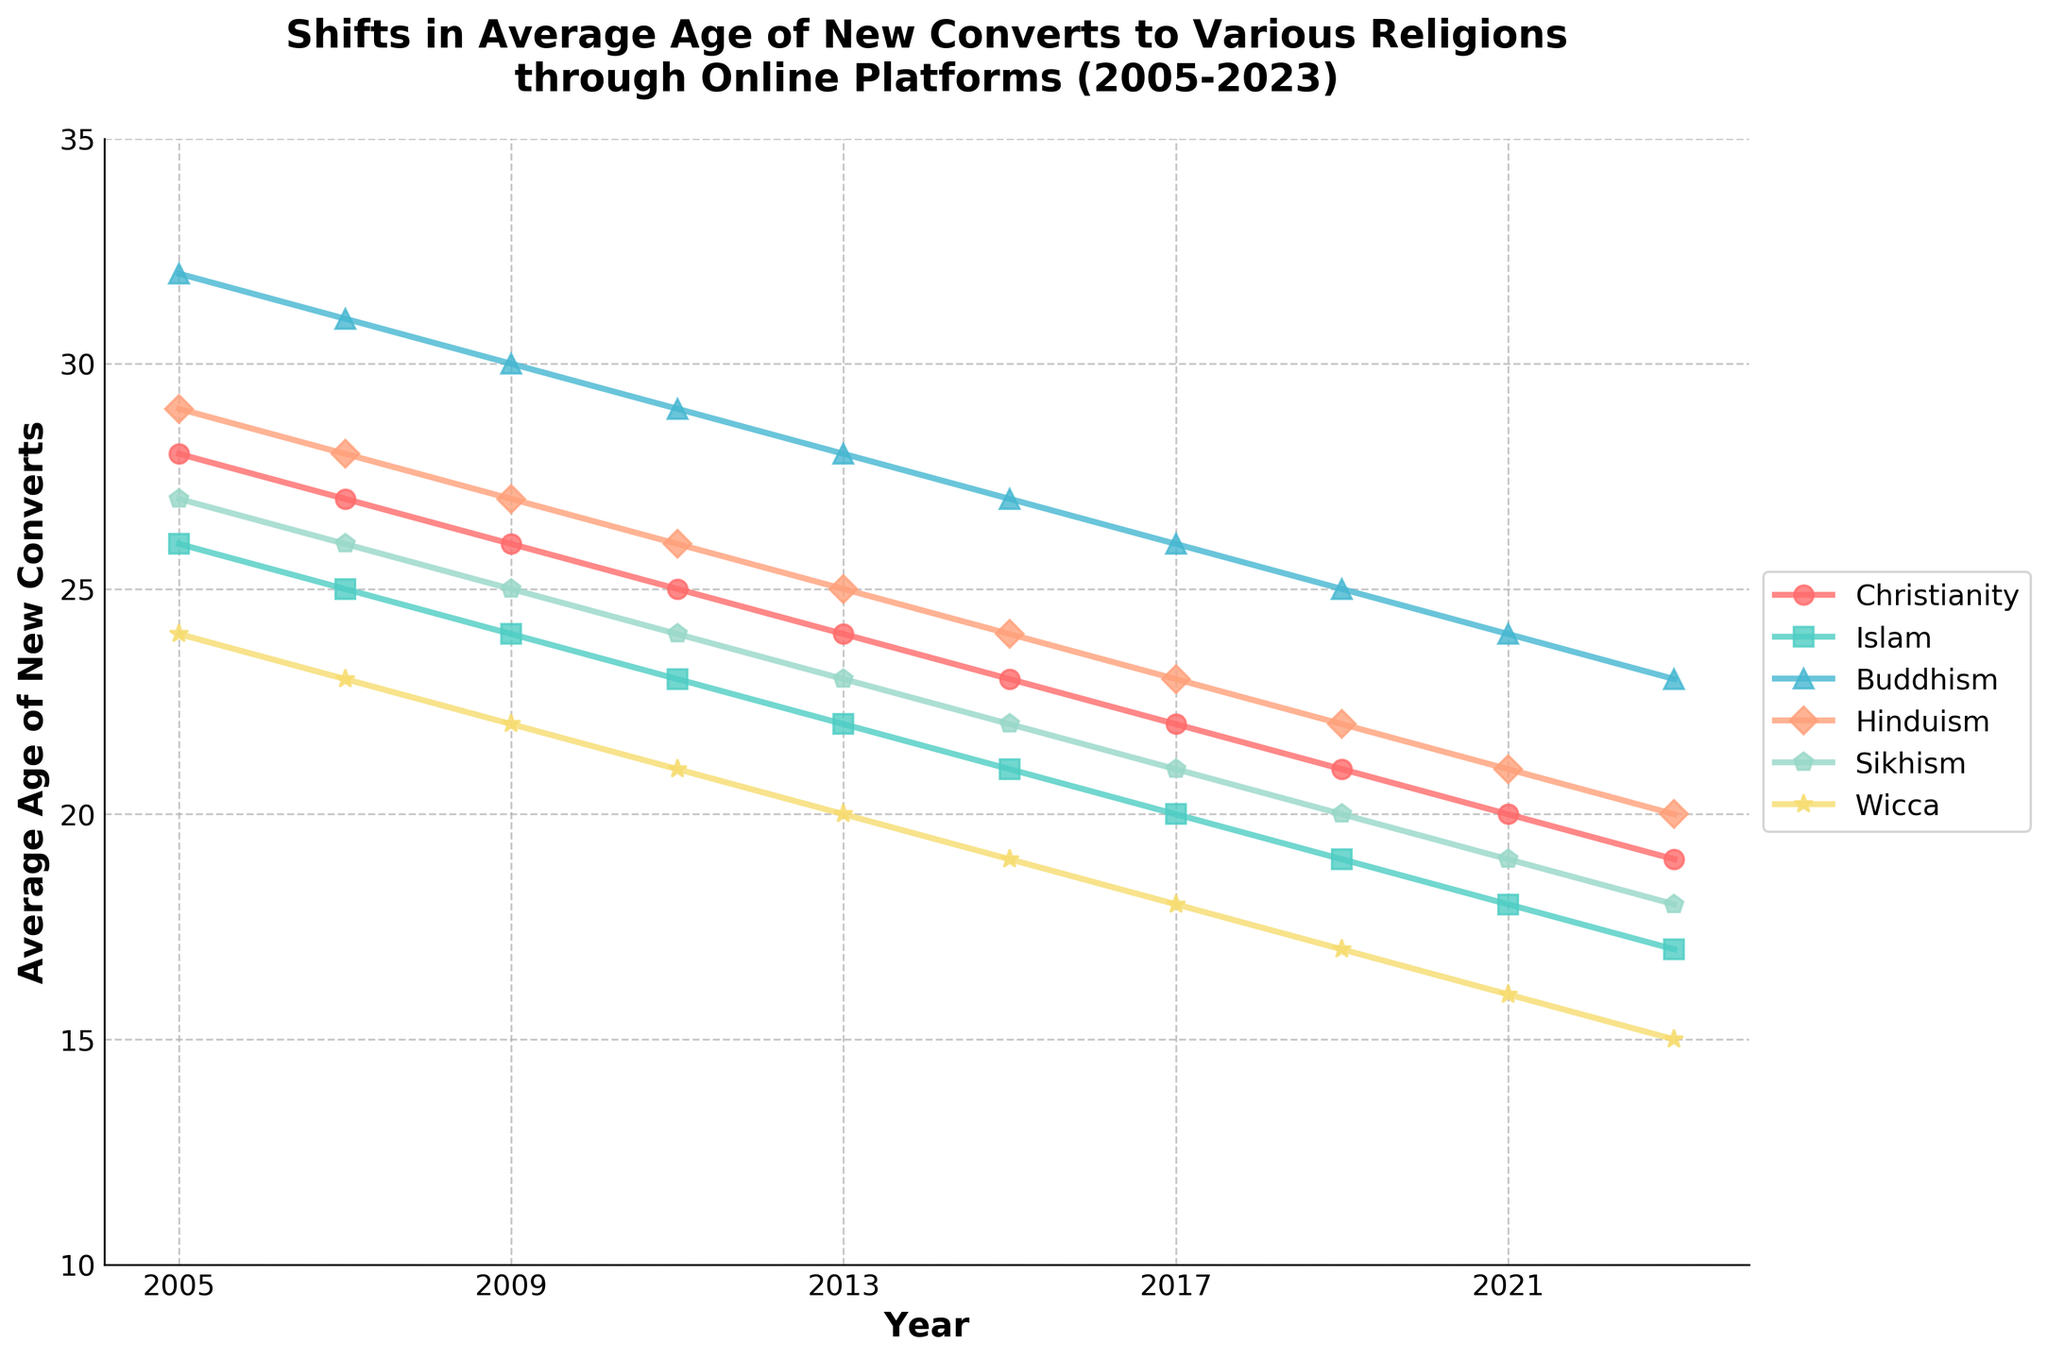what is the overall trend in the average age of new converts to Christianity from 2005 to 2023? The average age of new converts to Christianity shows a decreasing trend from 28 years in 2005 to 19 years in 2023.
Answer: Decreasing Which religion experienced the largest decrease in the average age of new converts from 2005 to 2023? By looking at the initial and final values for each religion, Wicca experienced the largest decrease, starting at 24 years in 2005 and dropping to 15 years in 2023.
Answer: Wicca In which year did the average age of new converts to Islam drop below 20? The average age of new converts to Islam dropped below 20 years in 2017 (20 years in 2017 and 19 years in 2019).
Answer: 2019 Between Hinduism and Sikhism, which one had a lower average age of new converts in 2015, and by how many years? In 2015, Hinduism had an average age of 24 years and Sikhism had an average age of 22 years. Sikhism's average age was lower by 2 years.
Answer: Sikhism, 2 years Which religion has the most gradual decline in the average age of new converts over these years? By visually inspecting the slope of the lines, Buddhism shows the most gradual decline, from 32 years in 2005 to 23 years in 2023.
Answer: Buddhism Compare the average age of new converts to Christianity and Buddhism in 2009. Which one had a higher average and by how much? In 2009, the average age for Christianity was 26 years and for Buddhism was 30 years. Buddhism had a higher average age by 4 years.
Answer: Buddhism, 4 years What is the difference in the average age of new converts to Wicca between 2013 and 2023? The average age for Wicca in 2013 was 20 years and in 2023 it is 15 years, so the difference is 5 years.
Answer: 5 years Which religion had its average age of new converts drop to 20 years first? By observing the lines, Islam reached the age of 20 first, achieving this by the year 2017.
Answer: Islam Is there any year where the average age of new converts to Buddhism and Hinduism is the same? If yes, which year? By looking at the graph, at no point do Buddhism and Hinduism lines intersect, meaning they never have the same average age at any given year.
Answer: No 